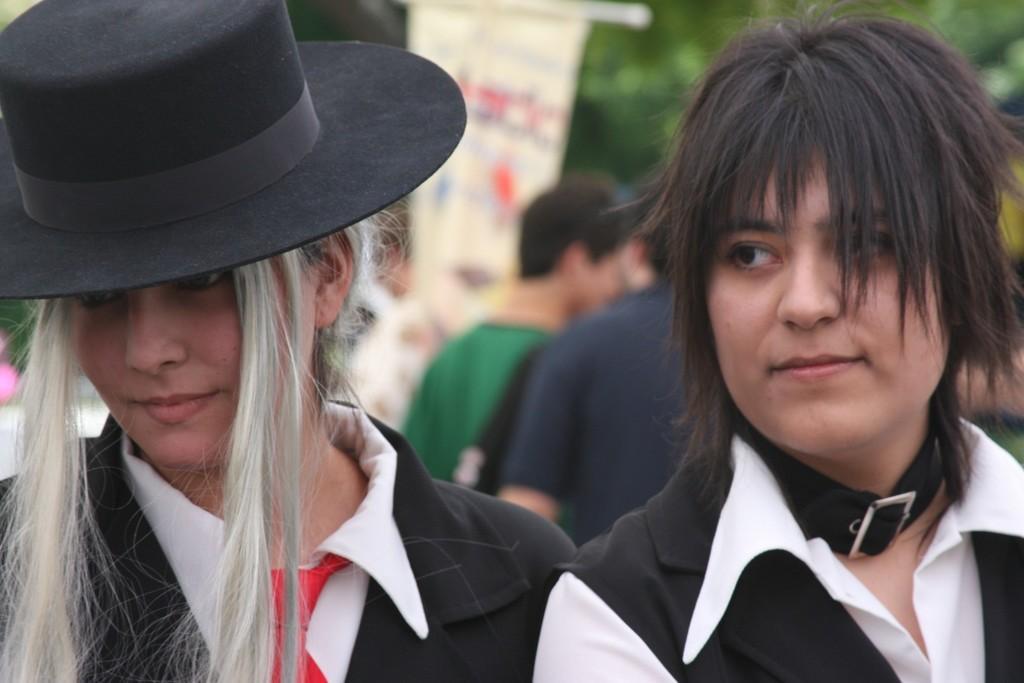Please provide a concise description of this image. In the foreground of this picture we can see the two persons wearing white color shirts and we can see a black color hat. In the background we can see the group of persons, trees and some other objects. 